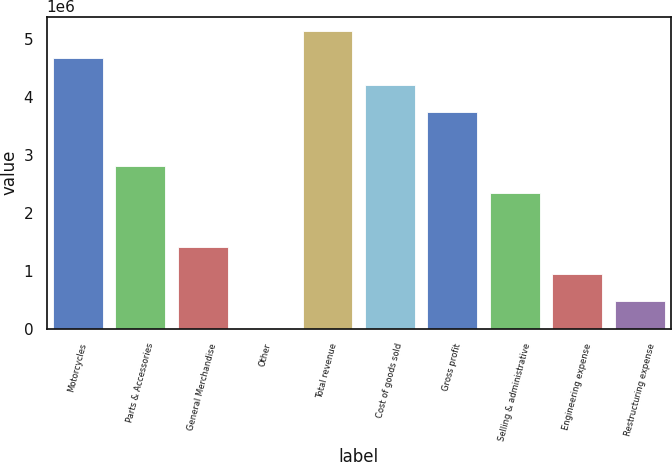Convert chart to OTSL. <chart><loc_0><loc_0><loc_500><loc_500><bar_chart><fcel>Motorcycles<fcel>Parts & Accessories<fcel>General Merchandise<fcel>Other<fcel>Total revenue<fcel>Cost of goods sold<fcel>Gross profit<fcel>Selling & administrative<fcel>Engineering expense<fcel>Restructuring expense<nl><fcel>4.66226e+06<fcel>2.80417e+06<fcel>1.4106e+06<fcel>17024<fcel>5.12679e+06<fcel>4.19774e+06<fcel>3.73322e+06<fcel>2.33964e+06<fcel>946072<fcel>481548<nl></chart> 